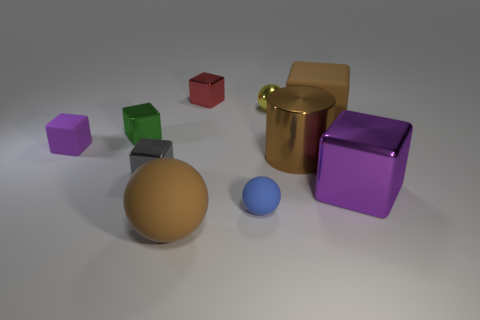Subtract all brown blocks. How many blocks are left? 5 Subtract all large blocks. How many blocks are left? 4 Subtract all green cubes. Subtract all cyan balls. How many cubes are left? 5 Subtract all cubes. How many objects are left? 4 Subtract all big brown metallic objects. Subtract all large purple shiny objects. How many objects are left? 8 Add 7 tiny shiny blocks. How many tiny shiny blocks are left? 10 Add 8 tiny blue spheres. How many tiny blue spheres exist? 9 Subtract 0 blue cubes. How many objects are left? 10 